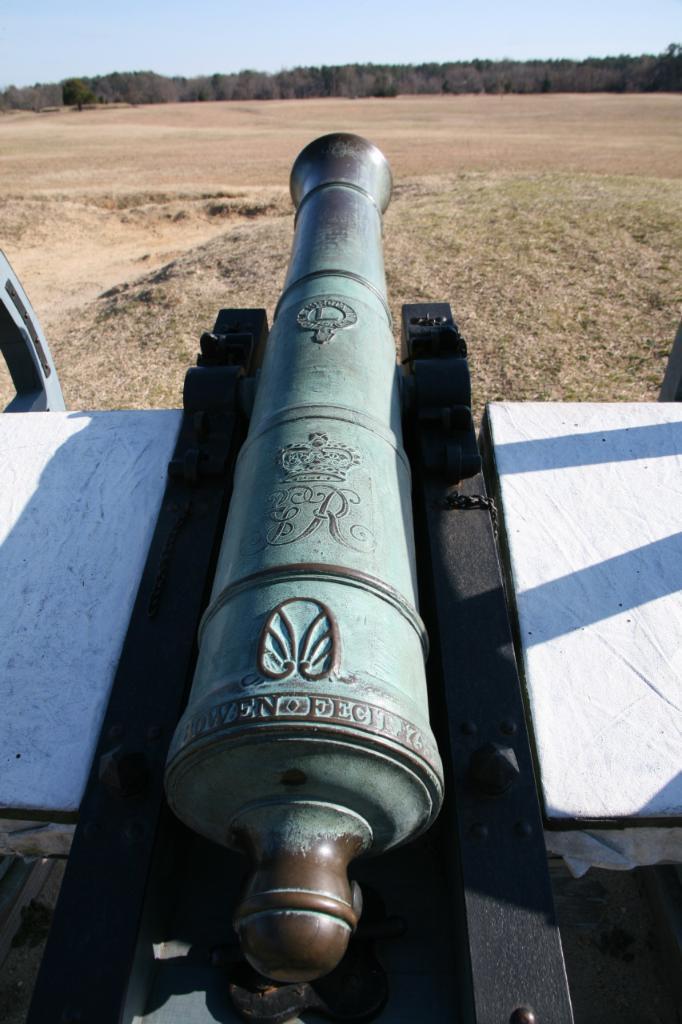Describe this image in one or two sentences. At the bottom of the picture, we see a cannon. In the background, there are trees. At the top of the picture, we see the sky. 